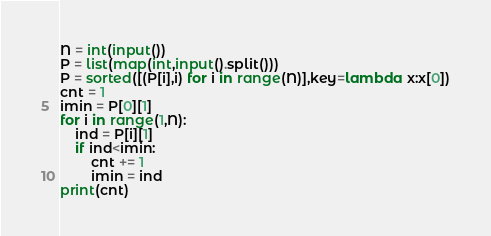Convert code to text. <code><loc_0><loc_0><loc_500><loc_500><_Python_>N = int(input())
P = list(map(int,input().split()))
P = sorted([(P[i],i) for i in range(N)],key=lambda x:x[0])
cnt = 1
imin = P[0][1]
for i in range(1,N):
    ind = P[i][1]
    if ind<imin:
        cnt += 1
        imin = ind
print(cnt)</code> 